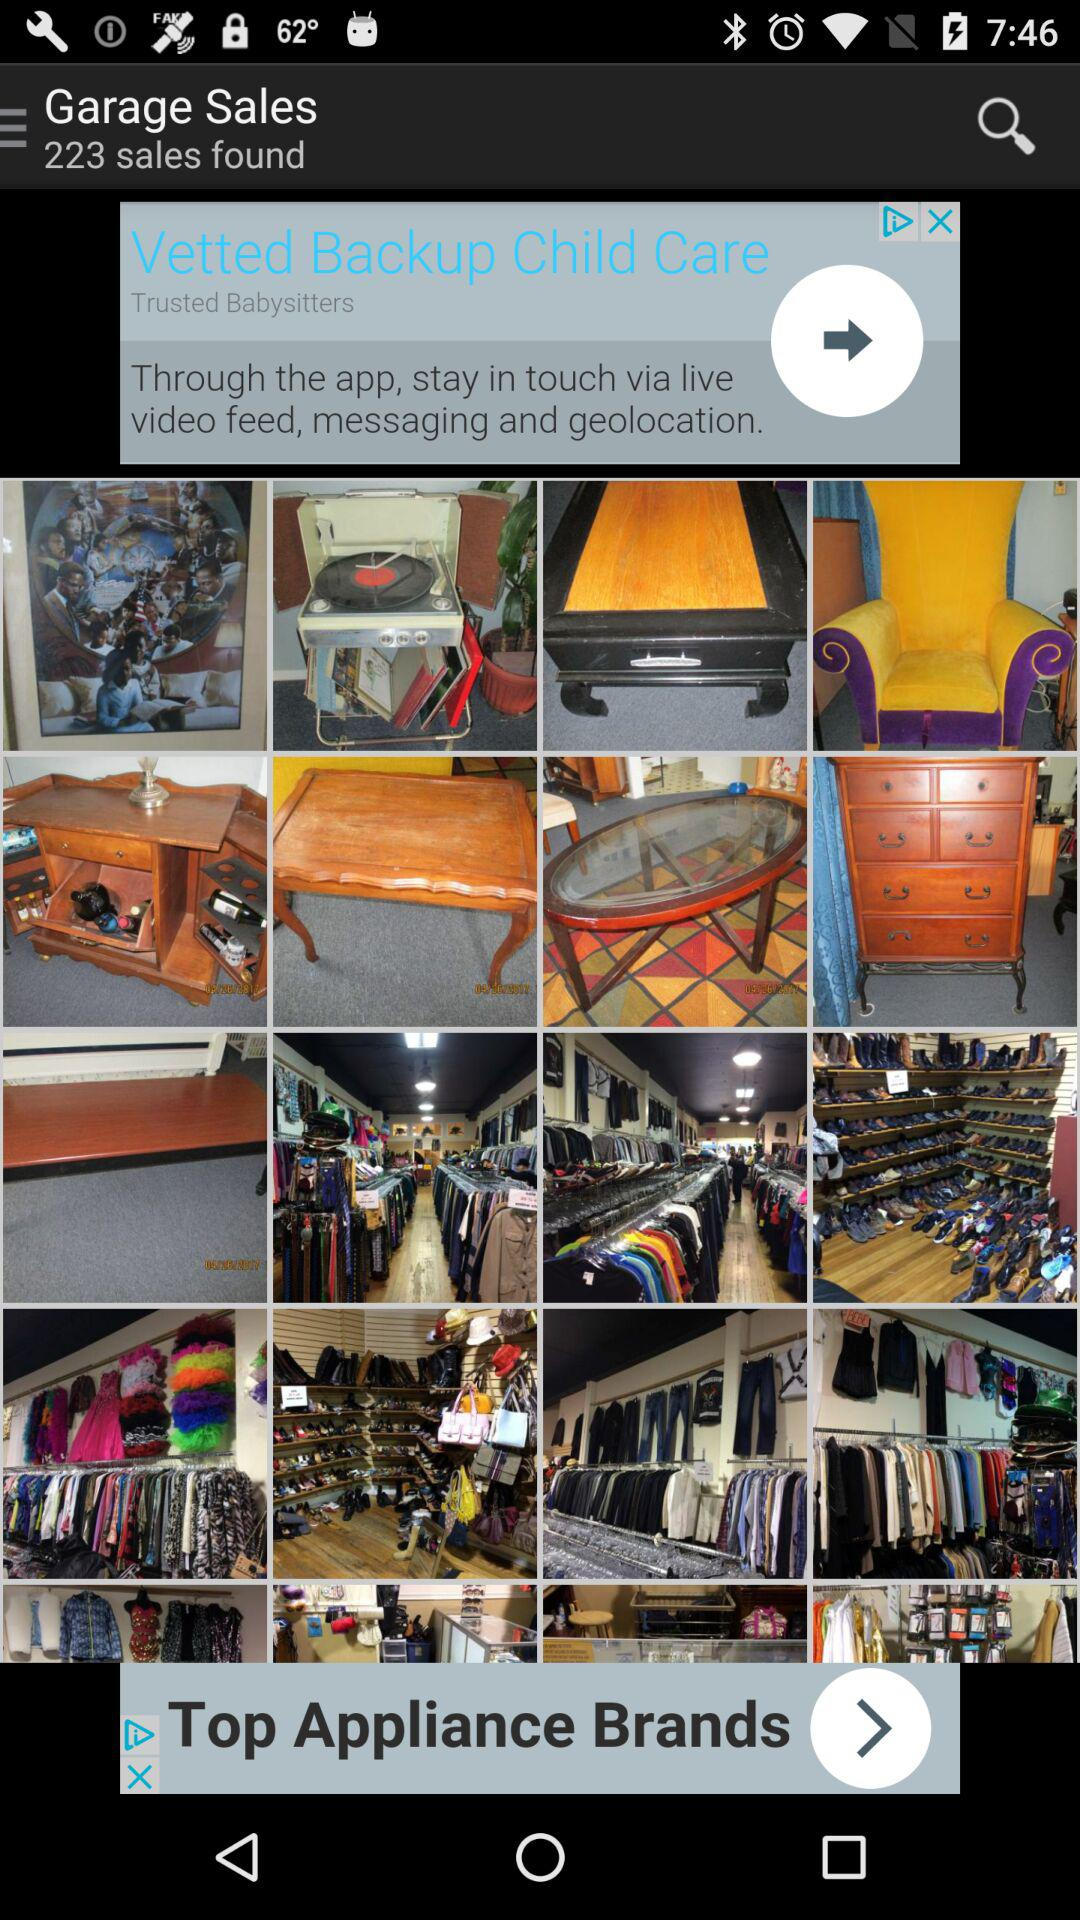What is the name of the application?
When the provided information is insufficient, respond with <no answer>. <no answer> 